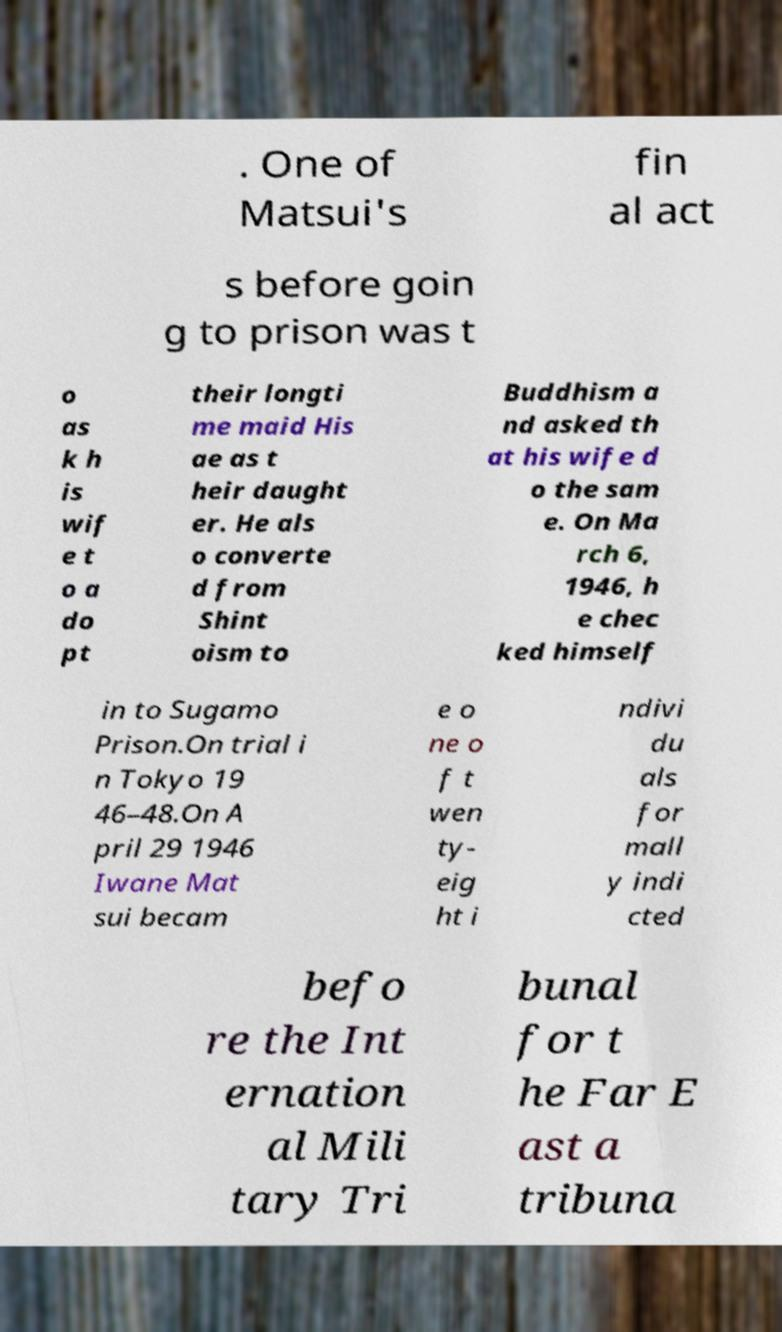Can you accurately transcribe the text from the provided image for me? . One of Matsui's fin al act s before goin g to prison was t o as k h is wif e t o a do pt their longti me maid His ae as t heir daught er. He als o converte d from Shint oism to Buddhism a nd asked th at his wife d o the sam e. On Ma rch 6, 1946, h e chec ked himself in to Sugamo Prison.On trial i n Tokyo 19 46–48.On A pril 29 1946 Iwane Mat sui becam e o ne o f t wen ty- eig ht i ndivi du als for mall y indi cted befo re the Int ernation al Mili tary Tri bunal for t he Far E ast a tribuna 